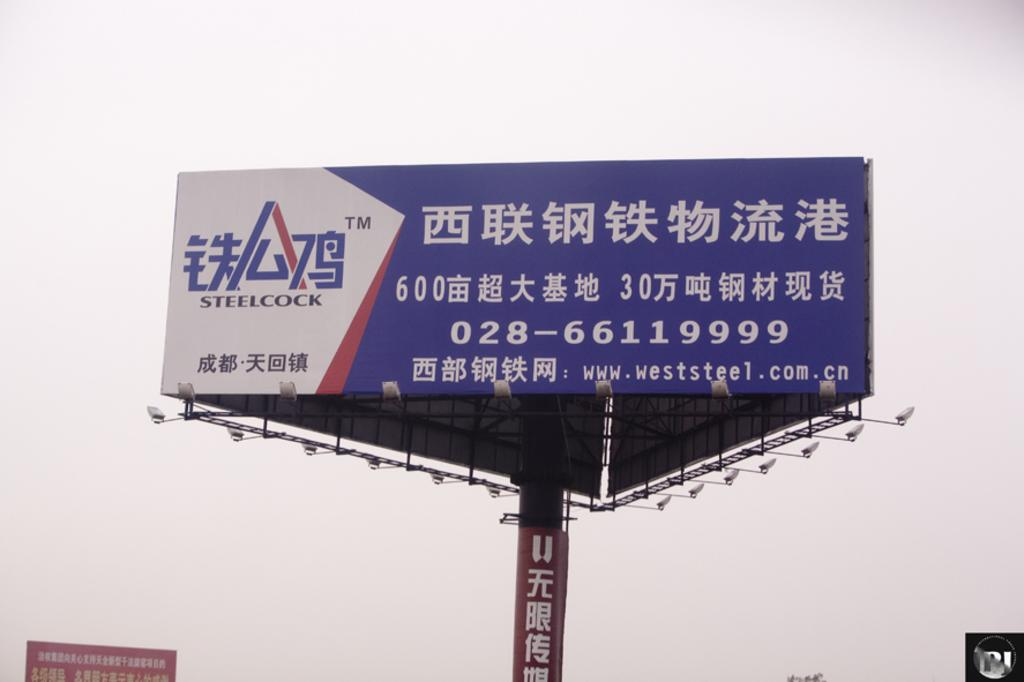<image>
Present a compact description of the photo's key features. A white and blue billboard written in Chinese by Steelcock. 